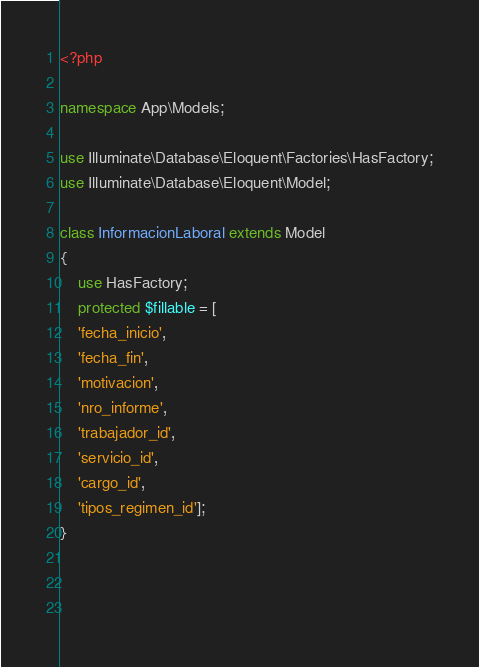Convert code to text. <code><loc_0><loc_0><loc_500><loc_500><_PHP_><?php

namespace App\Models;

use Illuminate\Database\Eloquent\Factories\HasFactory;
use Illuminate\Database\Eloquent\Model;

class InformacionLaboral extends Model
{
    use HasFactory;
    protected $fillable = [
    'fecha_inicio',
    'fecha_fin',
    'motivacion',
    'nro_informe',
    'trabajador_id',
    'servicio_id',
    'cargo_id',
    'tipos_regimen_id']; 
}

    
        </code> 